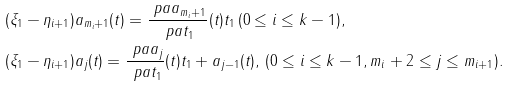<formula> <loc_0><loc_0><loc_500><loc_500>& ( \xi _ { 1 } - \eta _ { i + 1 } ) a _ { m _ { i } + 1 } ( t ) = \frac { \ p a a _ { m _ { i } + 1 } } { \ p a t _ { 1 } } ( t ) t _ { 1 } \, ( 0 \leq i \leq k - 1 ) , \\ & ( \xi _ { 1 } - \eta _ { i + 1 } ) a _ { j } ( t ) = \frac { \ p a a _ { j } } { \ p a t _ { 1 } } ( t ) t _ { 1 } + a _ { j - 1 } ( t ) , \, ( 0 \leq i \leq k - 1 , m _ { i } + 2 \leq j \leq m _ { i + 1 } ) .</formula> 